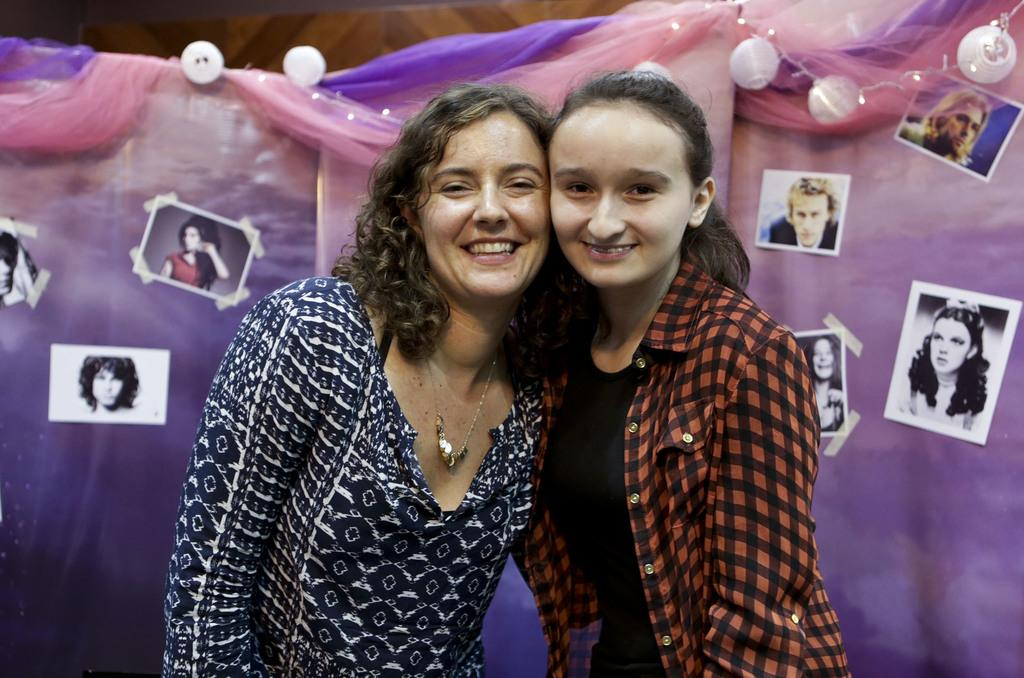How many people are present in the image? There are two women in the image. What can be seen in the background of the image? There is a curtain in the background of the image. What is attached to the curtain? Photos are attached to the curtain. What is the name of the daughter of the woman on the left in the image? There is no mention of a daughter or any names in the image, so it cannot be determined. 